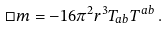Convert formula to latex. <formula><loc_0><loc_0><loc_500><loc_500>\Box m = - 1 6 \pi ^ { 2 } r ^ { 3 } T _ { a b } T ^ { a b } \, .</formula> 